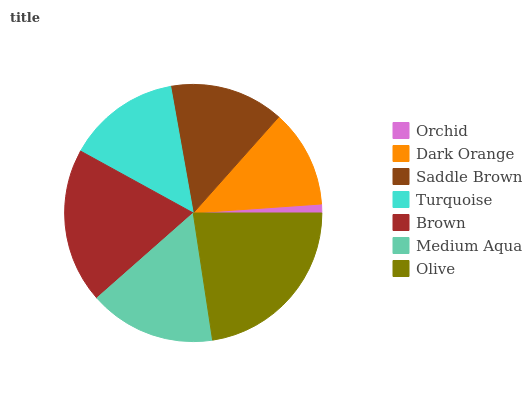Is Orchid the minimum?
Answer yes or no. Yes. Is Olive the maximum?
Answer yes or no. Yes. Is Dark Orange the minimum?
Answer yes or no. No. Is Dark Orange the maximum?
Answer yes or no. No. Is Dark Orange greater than Orchid?
Answer yes or no. Yes. Is Orchid less than Dark Orange?
Answer yes or no. Yes. Is Orchid greater than Dark Orange?
Answer yes or no. No. Is Dark Orange less than Orchid?
Answer yes or no. No. Is Saddle Brown the high median?
Answer yes or no. Yes. Is Saddle Brown the low median?
Answer yes or no. Yes. Is Dark Orange the high median?
Answer yes or no. No. Is Brown the low median?
Answer yes or no. No. 